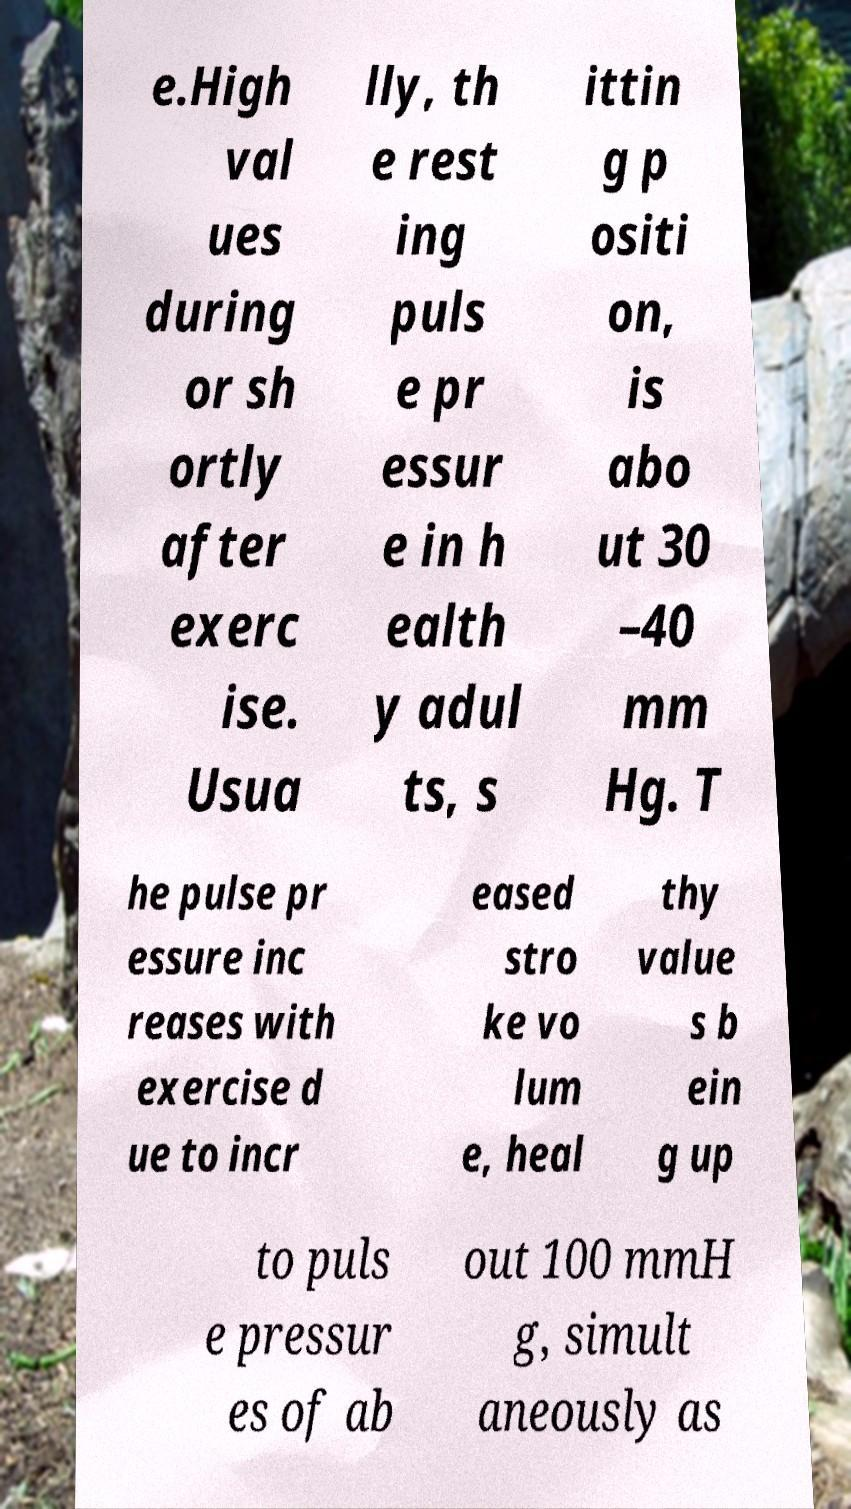Could you assist in decoding the text presented in this image and type it out clearly? e.High val ues during or sh ortly after exerc ise. Usua lly, th e rest ing puls e pr essur e in h ealth y adul ts, s ittin g p ositi on, is abo ut 30 –40 mm Hg. T he pulse pr essure inc reases with exercise d ue to incr eased stro ke vo lum e, heal thy value s b ein g up to puls e pressur es of ab out 100 mmH g, simult aneously as 